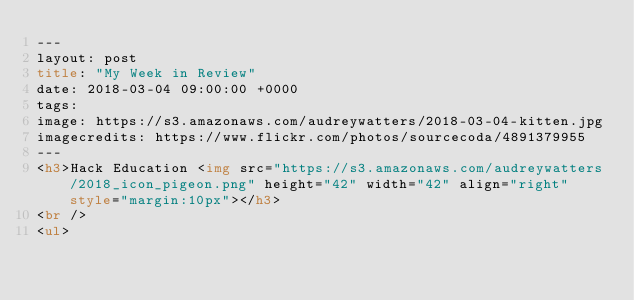<code> <loc_0><loc_0><loc_500><loc_500><_HTML_>---
layout: post
title: "My Week in Review"
date: 2018-03-04 09:00:00 +0000
tags:
image: https://s3.amazonaws.com/audreywatters/2018-03-04-kitten.jpg
imagecredits: https://www.flickr.com/photos/sourcecoda/4891379955
---
<h3>Hack Education <img src="https://s3.amazonaws.com/audreywatters/2018_icon_pigeon.png" height="42" width="42" align="right" style="margin:10px"></h3>
<br />
<ul></code> 